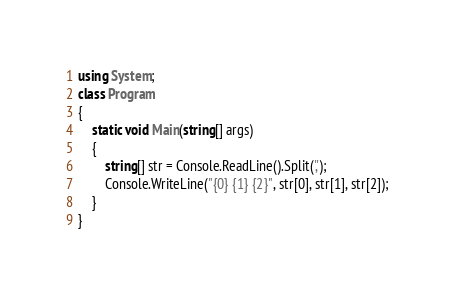<code> <loc_0><loc_0><loc_500><loc_500><_C#_>using System;
class Program
{
    static void Main(string[] args)
    {
        string[] str = Console.ReadLine().Split(',');
        Console.WriteLine("{0} {1} {2}", str[0], str[1], str[2]);
    }
}</code> 